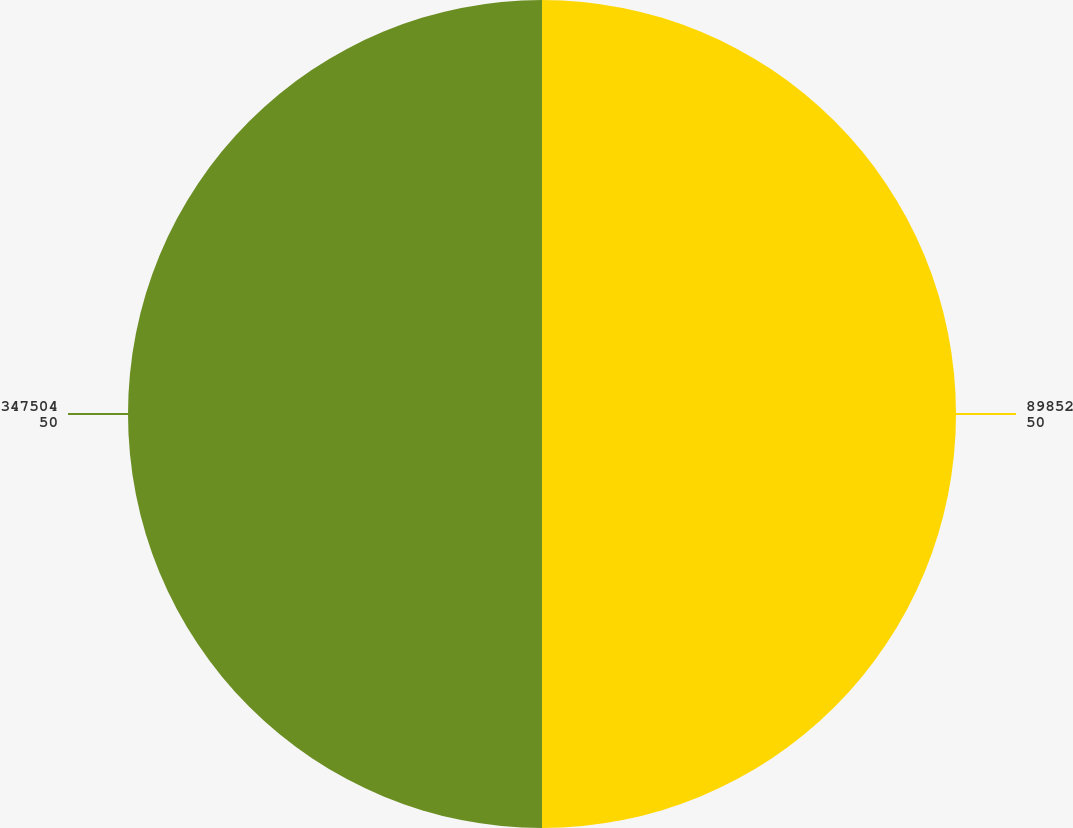Convert chart to OTSL. <chart><loc_0><loc_0><loc_500><loc_500><pie_chart><fcel>89852<fcel>347504<nl><fcel>50.0%<fcel>50.0%<nl></chart> 